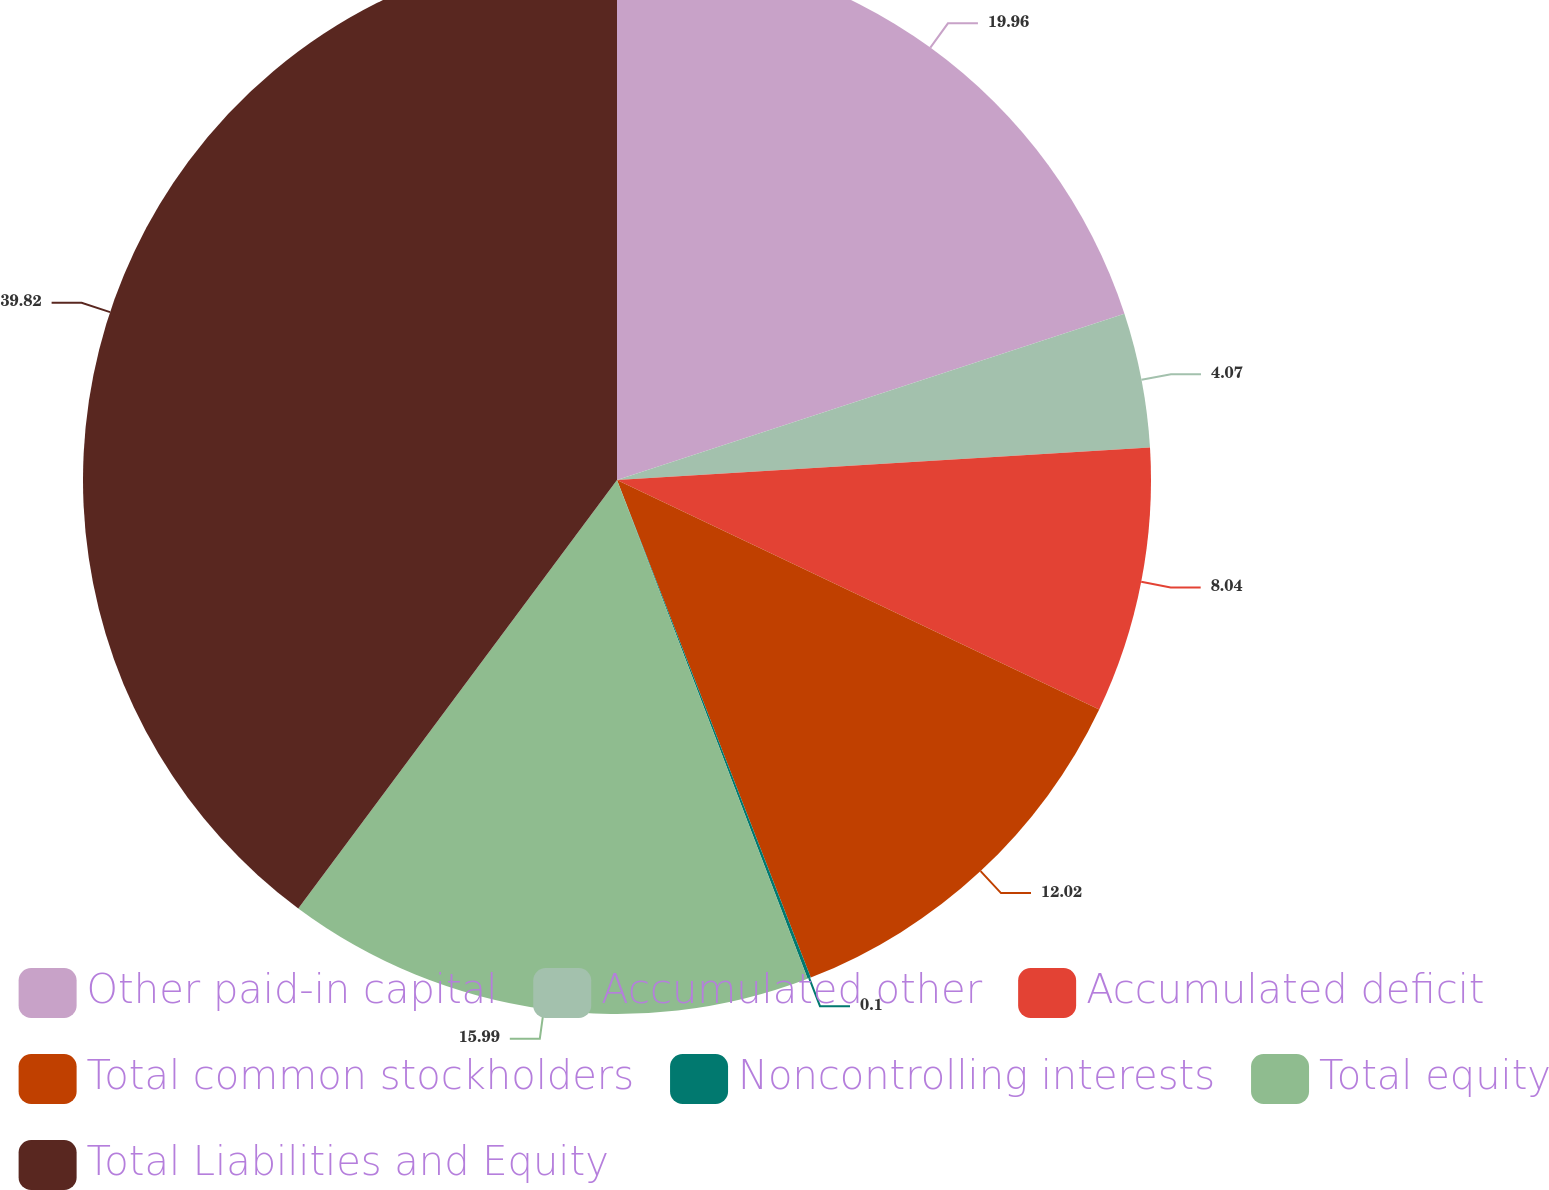<chart> <loc_0><loc_0><loc_500><loc_500><pie_chart><fcel>Other paid-in capital<fcel>Accumulated other<fcel>Accumulated deficit<fcel>Total common stockholders<fcel>Noncontrolling interests<fcel>Total equity<fcel>Total Liabilities and Equity<nl><fcel>19.96%<fcel>4.07%<fcel>8.04%<fcel>12.02%<fcel>0.1%<fcel>15.99%<fcel>39.82%<nl></chart> 